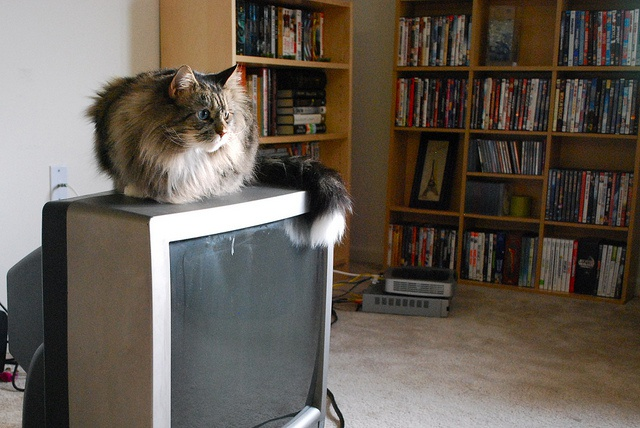Describe the objects in this image and their specific colors. I can see tv in lightgray, gray, white, and black tones, book in lightgray, black, gray, and maroon tones, cat in lightgray, black, and gray tones, book in lightgray, black, gray, and maroon tones, and book in lightgray, black, gray, and olive tones in this image. 